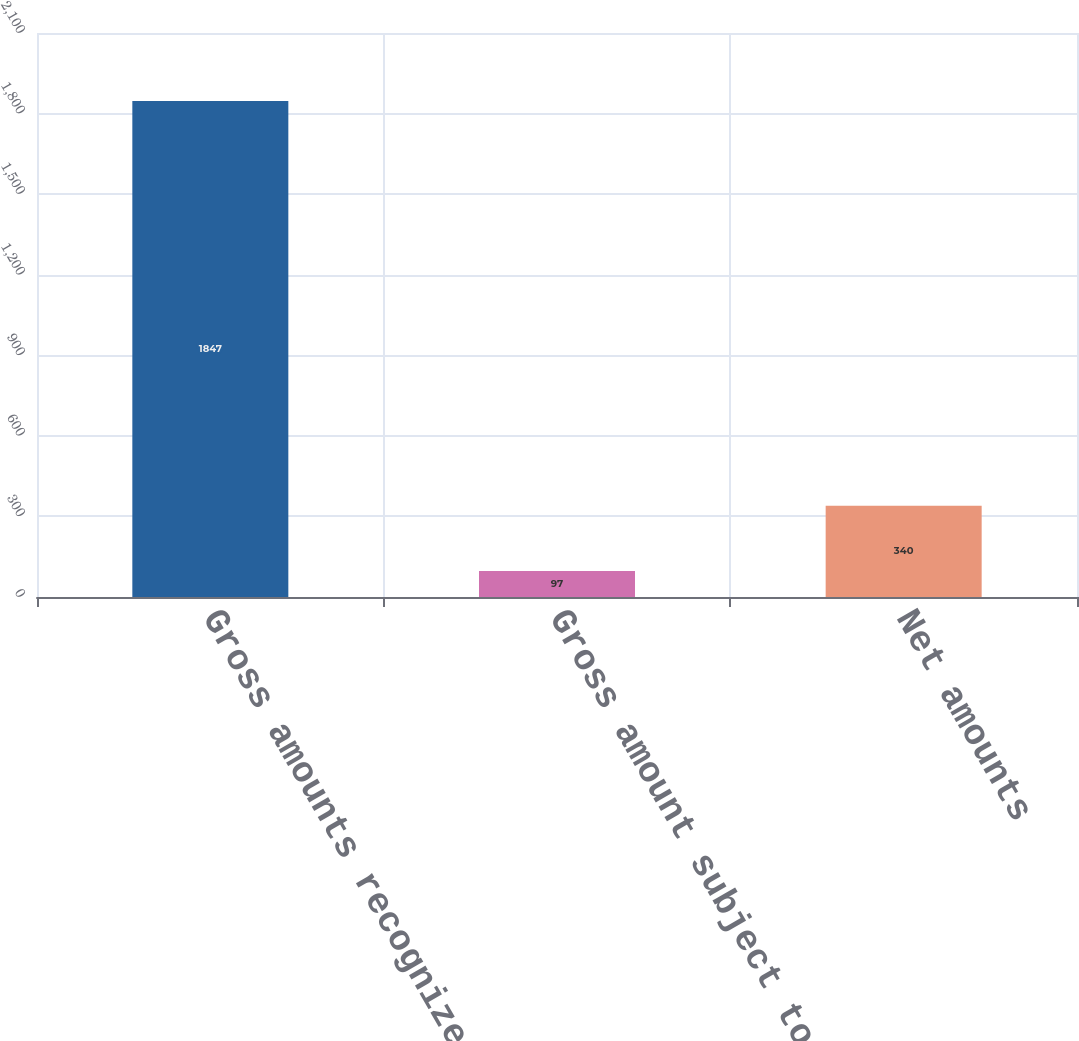Convert chart to OTSL. <chart><loc_0><loc_0><loc_500><loc_500><bar_chart><fcel>Gross amounts recognized in<fcel>Gross amount subject to offset<fcel>Net amounts<nl><fcel>1847<fcel>97<fcel>340<nl></chart> 